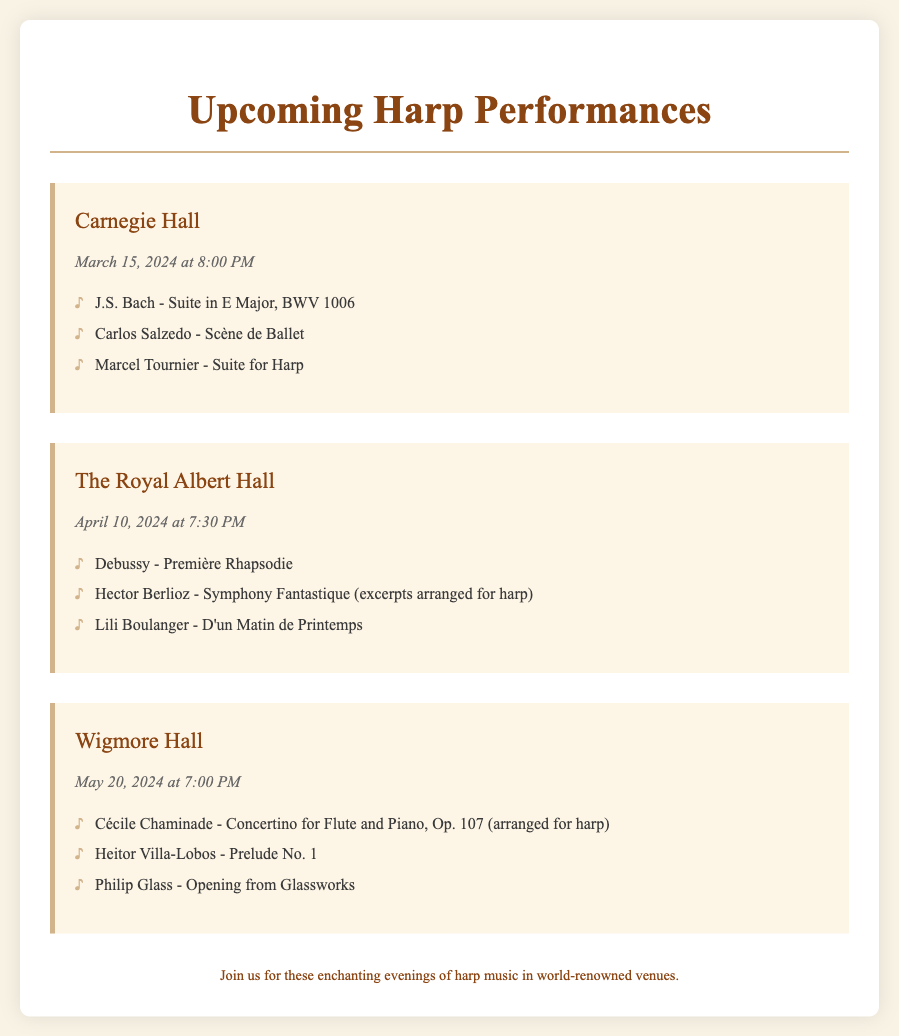What is the venue for the concert on March 15, 2024? The venue for the concert on that date is specified in the document under the Carnegie Hall section.
Answer: Carnegie Hall What is the repertoire for the April 10, 2024 concert? The repertoire can be found listed under the concert details for The Royal Albert Hall.
Answer: Debussy - Première Rhapsodie; Hector Berlioz - Symphony Fantastique; Lili Boulanger - D'un Matin de Printemps What time does the concert at Wigmore Hall start? The start time for the concert at Wigmore Hall is indicated in the date-time section of that concert's details.
Answer: 7:00 PM How many pieces are listed for the concert at Carnegie Hall? The number of pieces can be counted from the repertoire list provided for that specific concert.
Answer: 3 Which composer is featured in the repertoire for the May 20, 2024 concert? The repertoire includes works by multiple composers; one can be identified from the list presented for the Wigmore Hall concert.
Answer: Cécile Chaminade What is the date of the concert at The Royal Albert Hall? The date is clearly stated in the document under The Royal Albert Hall concert information.
Answer: April 10, 2024 How many concerts are scheduled in total? The total number of concerts can be counted from the number of concert sections present in the document.
Answer: 3 What is the theme of the footer message? The footer summarizes the nature of the concerts, indicating what attendees can expect.
Answer: Enchanting evenings of harp music 